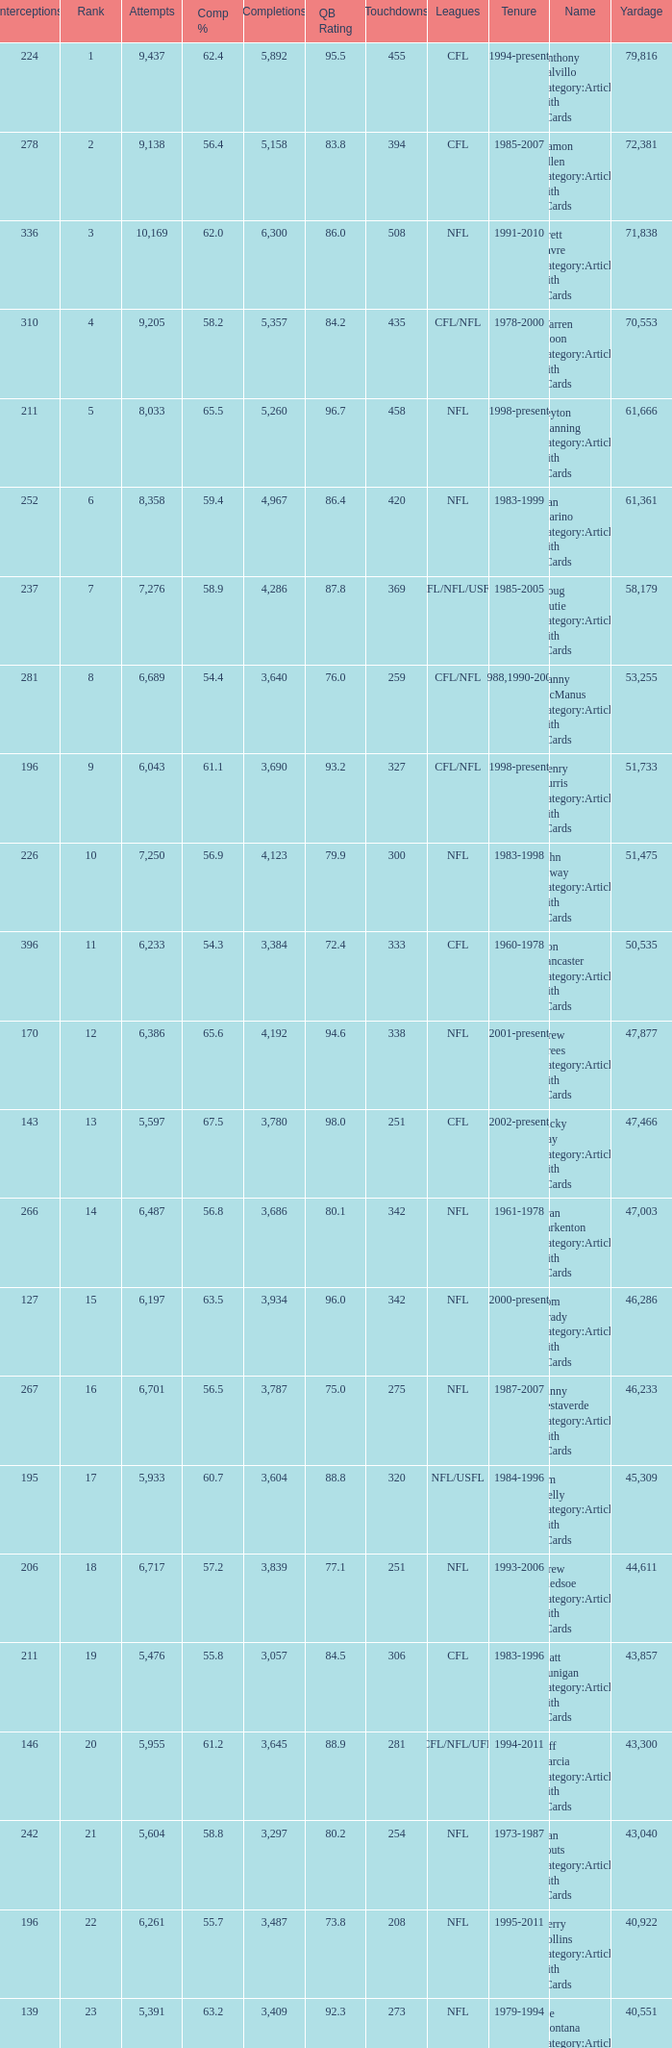What is the number of interceptions with less than 3,487 completions , more than 40,551 yardage, and the comp % is 55.8? 211.0. 